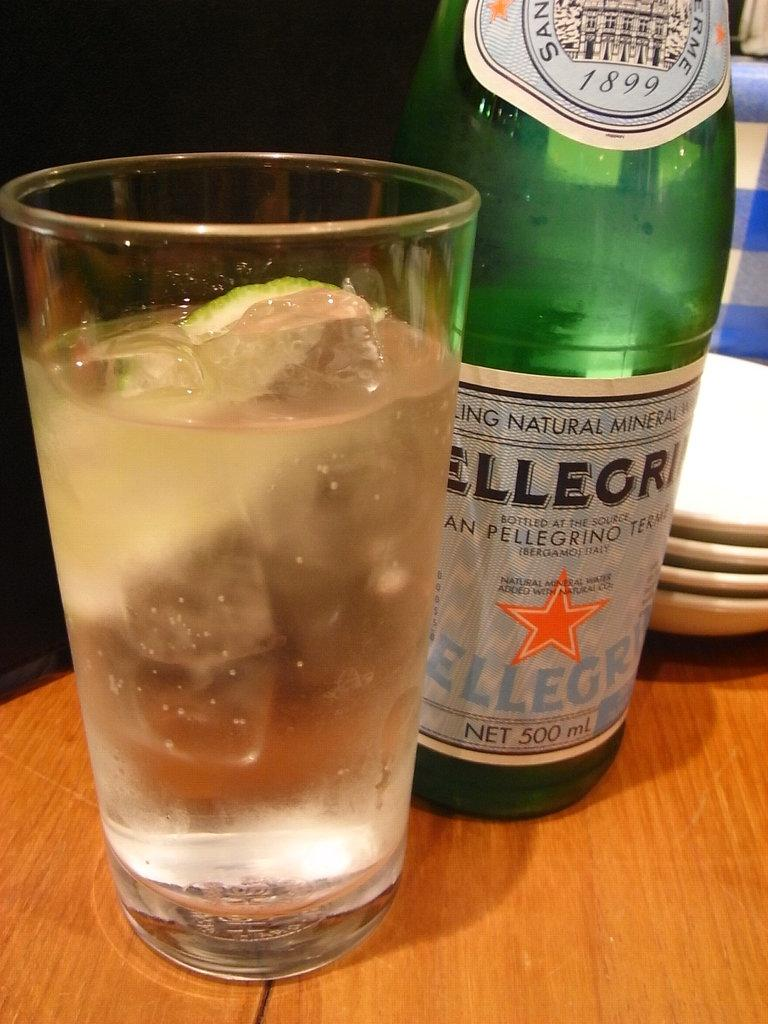Provide a one-sentence caption for the provided image. A glass of sparkling water sits next to a Pelligrino bottle. 